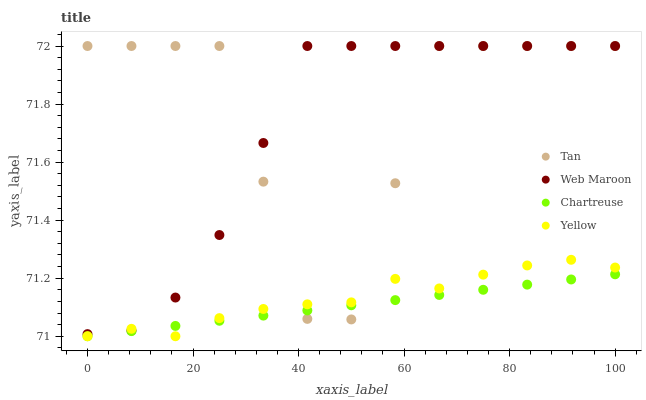Does Chartreuse have the minimum area under the curve?
Answer yes or no. Yes. Does Tan have the maximum area under the curve?
Answer yes or no. Yes. Does Web Maroon have the minimum area under the curve?
Answer yes or no. No. Does Web Maroon have the maximum area under the curve?
Answer yes or no. No. Is Chartreuse the smoothest?
Answer yes or no. Yes. Is Tan the roughest?
Answer yes or no. Yes. Is Web Maroon the smoothest?
Answer yes or no. No. Is Web Maroon the roughest?
Answer yes or no. No. Does Chartreuse have the lowest value?
Answer yes or no. Yes. Does Web Maroon have the lowest value?
Answer yes or no. No. Does Web Maroon have the highest value?
Answer yes or no. Yes. Does Chartreuse have the highest value?
Answer yes or no. No. Is Chartreuse less than Web Maroon?
Answer yes or no. Yes. Is Web Maroon greater than Chartreuse?
Answer yes or no. Yes. Does Tan intersect Yellow?
Answer yes or no. Yes. Is Tan less than Yellow?
Answer yes or no. No. Is Tan greater than Yellow?
Answer yes or no. No. Does Chartreuse intersect Web Maroon?
Answer yes or no. No. 